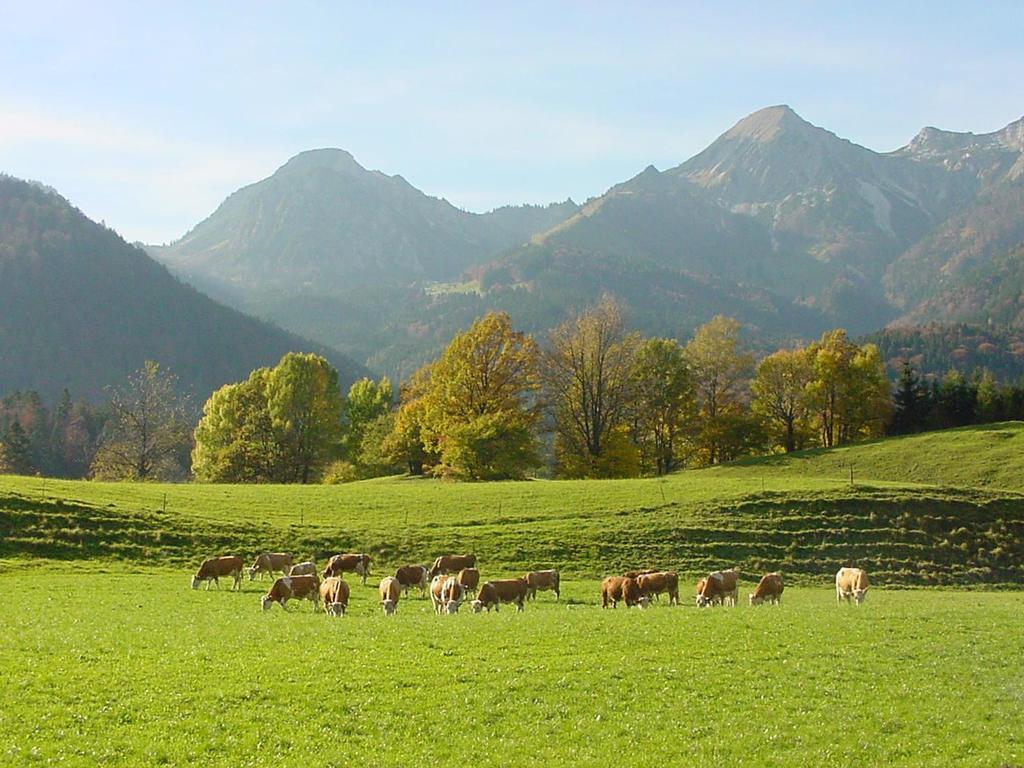What is the main setting of the image? The image depicts a field. What type of creatures can be seen in the field? There are animals in the field. Where are the animals located in the image? The animals are on the grass floor. What can be seen in the distance in the image? There are trees and mountains visible in the background. What is the price of the pocket in the image? There is no pocket present in the image, so it is not possible to determine its price. Are there any bears visible in the image? There are no bears visible in the image; the animals present are not bears. 